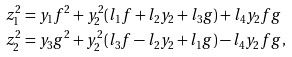<formula> <loc_0><loc_0><loc_500><loc_500>z _ { 1 } ^ { 2 } & = y _ { 1 } f ^ { 2 } + y _ { 2 } ^ { 2 } ( l _ { 1 } f + l _ { 2 } y _ { 2 } + l _ { 3 } g ) + l _ { 4 } y _ { 2 } f g \\ z _ { 2 } ^ { 2 } & = y _ { 3 } g ^ { 2 } + y _ { 2 } ^ { 2 } ( l _ { 3 } f - l _ { 2 } y _ { 2 } + l _ { 1 } g ) - l _ { 4 } y _ { 2 } f g ,</formula> 